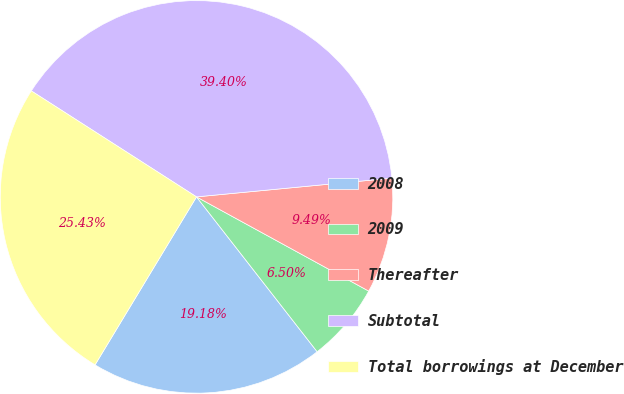<chart> <loc_0><loc_0><loc_500><loc_500><pie_chart><fcel>2008<fcel>2009<fcel>Thereafter<fcel>Subtotal<fcel>Total borrowings at December<nl><fcel>19.18%<fcel>6.5%<fcel>9.49%<fcel>39.4%<fcel>25.43%<nl></chart> 